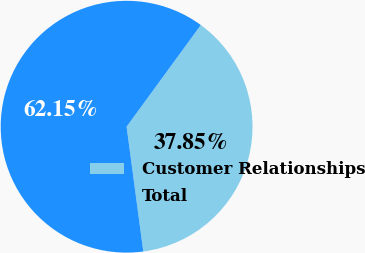Convert chart. <chart><loc_0><loc_0><loc_500><loc_500><pie_chart><fcel>Customer Relationships<fcel>Total<nl><fcel>37.85%<fcel>62.15%<nl></chart> 